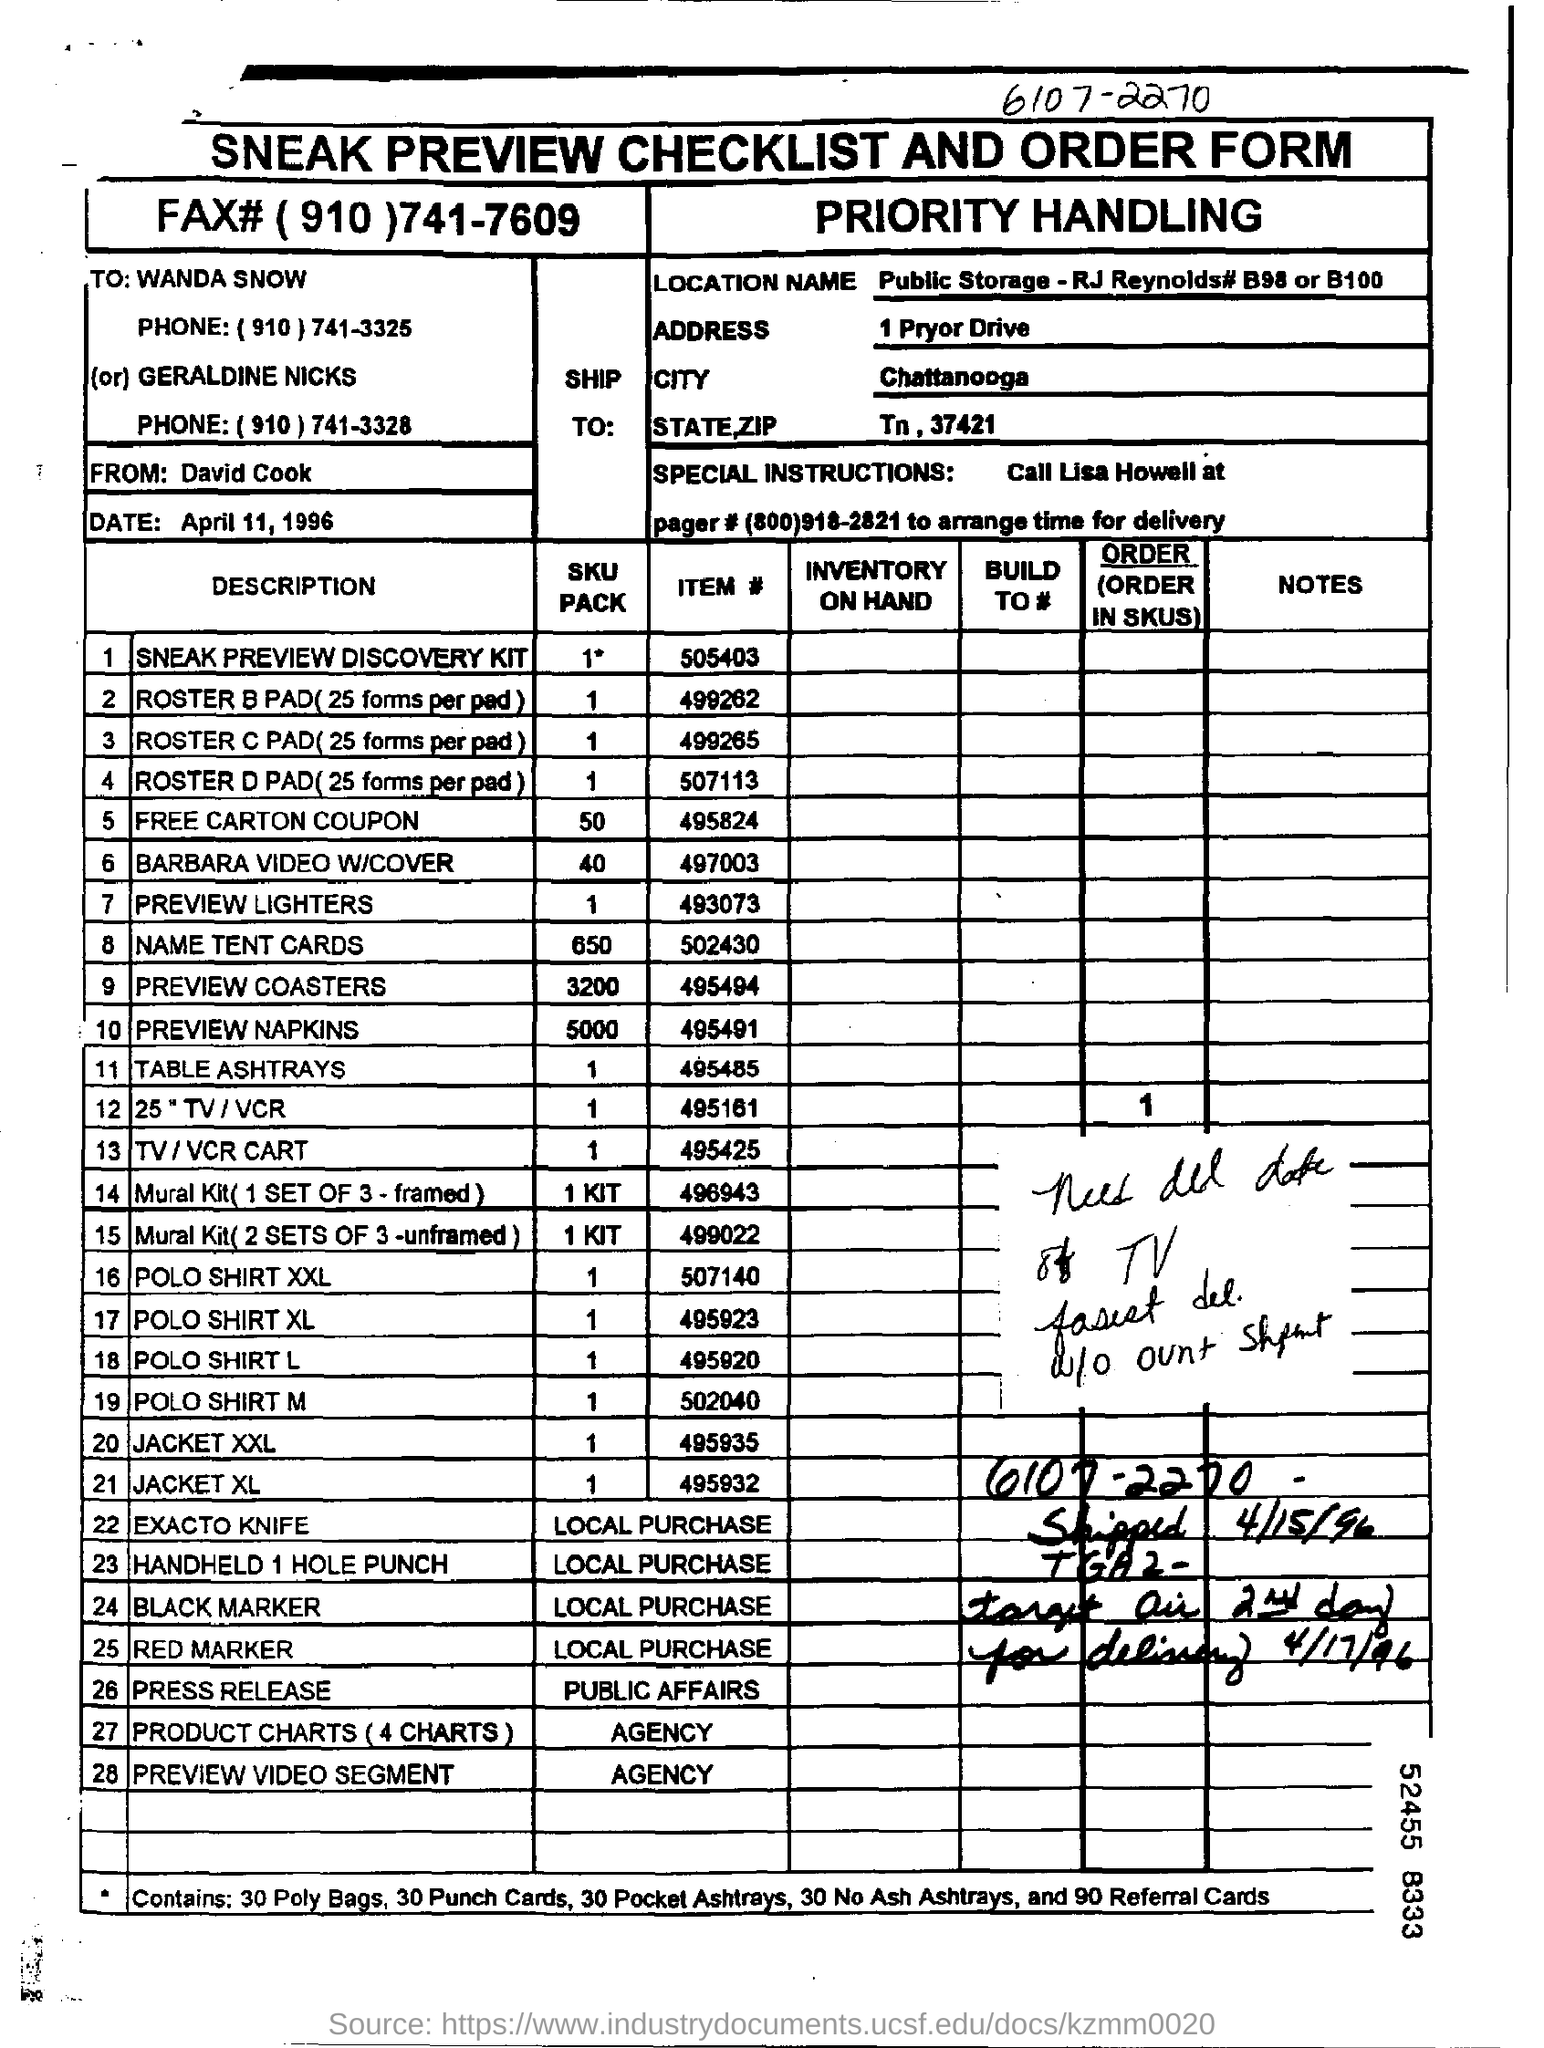Identify some key points in this picture. The city is Chattanooga. It is from David Cook. The date is April 11, 1996. The SKU Pack for Item # 502430 is 650. The letter is addressed to Wanda Snow. 